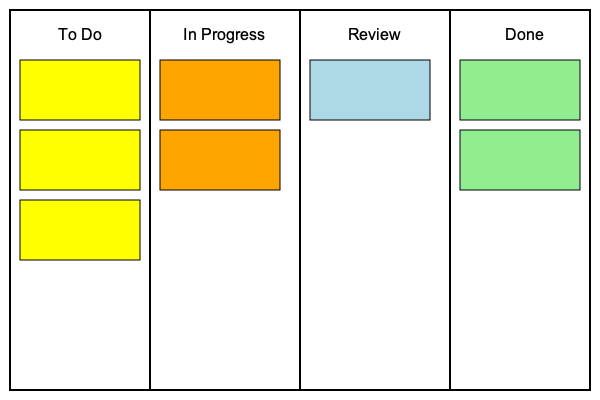In the given Kanban board layout, which column represents the bottleneck in the workflow, and why is it considered a bottleneck? To identify the bottleneck in the Kanban board layout, we need to analyze the work distribution across columns:

1. Examine each column:
   - "To Do": Contains 3 tasks
   - "In Progress": Contains 2 tasks
   - "Review": Contains 1 task
   - "Done": Contains 2 tasks

2. Identify the column with the most tasks relative to its capacity:
   The "In Progress" column has 2 tasks, which is high compared to the subsequent columns.

3. Analyze the flow of work:
   Tasks are moving from "To Do" to "In Progress", but fewer tasks are moving to "Review" and "Done".

4. Consider the nature of the "In Progress" column:
   This column represents active work being done by team members.

5. Evaluate the impact on workflow:
   The accumulation of tasks in "In Progress" suggests that work is entering this stage faster than it's being completed and moved to the next stage.

6. Conclude:
   The "In Progress" column is the bottleneck because it has a high number of tasks compared to the subsequent columns, indicating that work is piling up in this stage and not flowing smoothly to the next stages of the workflow.
Answer: The "In Progress" column, due to task accumulation hindering workflow. 